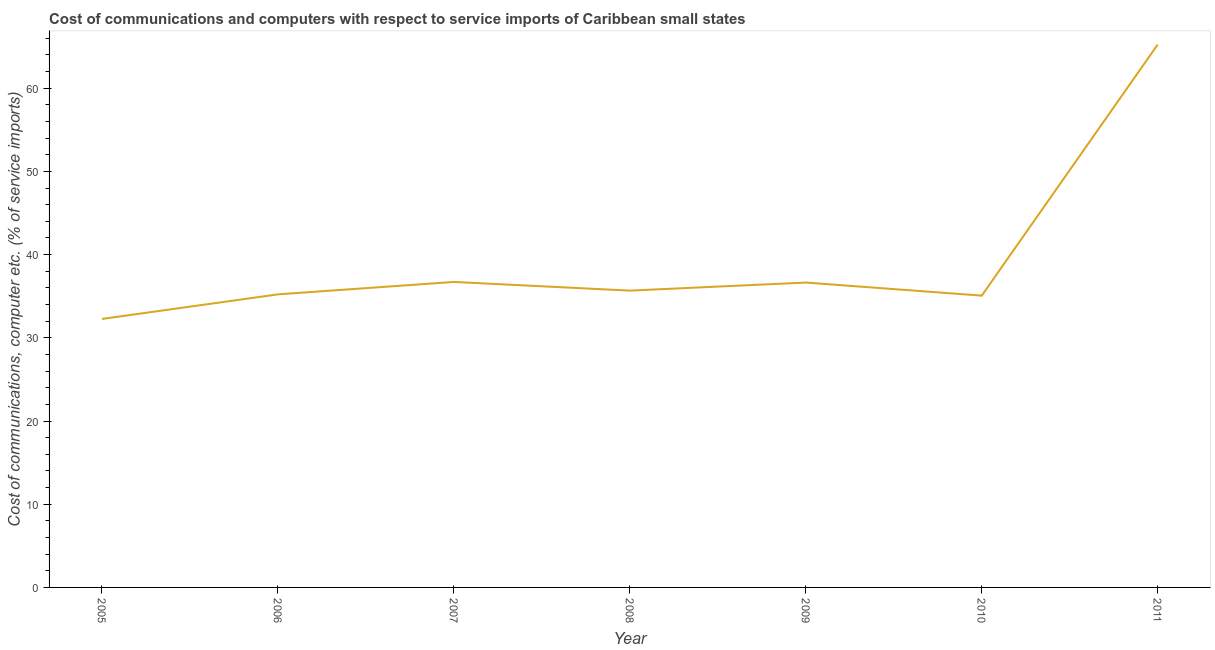What is the cost of communications and computer in 2006?
Give a very brief answer. 35.22. Across all years, what is the maximum cost of communications and computer?
Give a very brief answer. 65.25. Across all years, what is the minimum cost of communications and computer?
Your response must be concise. 32.27. In which year was the cost of communications and computer maximum?
Your response must be concise. 2011. In which year was the cost of communications and computer minimum?
Keep it short and to the point. 2005. What is the sum of the cost of communications and computer?
Your answer should be very brief. 276.83. What is the difference between the cost of communications and computer in 2006 and 2011?
Your answer should be compact. -30.02. What is the average cost of communications and computer per year?
Provide a succinct answer. 39.55. What is the median cost of communications and computer?
Make the answer very short. 35.67. What is the ratio of the cost of communications and computer in 2006 to that in 2007?
Your answer should be compact. 0.96. Is the cost of communications and computer in 2005 less than that in 2009?
Provide a short and direct response. Yes. Is the difference between the cost of communications and computer in 2007 and 2009 greater than the difference between any two years?
Provide a succinct answer. No. What is the difference between the highest and the second highest cost of communications and computer?
Offer a very short reply. 28.53. Is the sum of the cost of communications and computer in 2010 and 2011 greater than the maximum cost of communications and computer across all years?
Your answer should be very brief. Yes. What is the difference between the highest and the lowest cost of communications and computer?
Your answer should be very brief. 32.98. Are the values on the major ticks of Y-axis written in scientific E-notation?
Make the answer very short. No. What is the title of the graph?
Offer a very short reply. Cost of communications and computers with respect to service imports of Caribbean small states. What is the label or title of the Y-axis?
Your answer should be compact. Cost of communications, computer etc. (% of service imports). What is the Cost of communications, computer etc. (% of service imports) in 2005?
Offer a terse response. 32.27. What is the Cost of communications, computer etc. (% of service imports) of 2006?
Your response must be concise. 35.22. What is the Cost of communications, computer etc. (% of service imports) in 2007?
Offer a terse response. 36.71. What is the Cost of communications, computer etc. (% of service imports) in 2008?
Give a very brief answer. 35.67. What is the Cost of communications, computer etc. (% of service imports) in 2009?
Offer a terse response. 36.64. What is the Cost of communications, computer etc. (% of service imports) of 2010?
Your response must be concise. 35.07. What is the Cost of communications, computer etc. (% of service imports) in 2011?
Your response must be concise. 65.25. What is the difference between the Cost of communications, computer etc. (% of service imports) in 2005 and 2006?
Give a very brief answer. -2.96. What is the difference between the Cost of communications, computer etc. (% of service imports) in 2005 and 2007?
Make the answer very short. -4.45. What is the difference between the Cost of communications, computer etc. (% of service imports) in 2005 and 2008?
Ensure brevity in your answer.  -3.4. What is the difference between the Cost of communications, computer etc. (% of service imports) in 2005 and 2009?
Make the answer very short. -4.37. What is the difference between the Cost of communications, computer etc. (% of service imports) in 2005 and 2010?
Provide a succinct answer. -2.8. What is the difference between the Cost of communications, computer etc. (% of service imports) in 2005 and 2011?
Offer a terse response. -32.98. What is the difference between the Cost of communications, computer etc. (% of service imports) in 2006 and 2007?
Keep it short and to the point. -1.49. What is the difference between the Cost of communications, computer etc. (% of service imports) in 2006 and 2008?
Your answer should be compact. -0.45. What is the difference between the Cost of communications, computer etc. (% of service imports) in 2006 and 2009?
Offer a very short reply. -1.42. What is the difference between the Cost of communications, computer etc. (% of service imports) in 2006 and 2010?
Keep it short and to the point. 0.15. What is the difference between the Cost of communications, computer etc. (% of service imports) in 2006 and 2011?
Your answer should be very brief. -30.02. What is the difference between the Cost of communications, computer etc. (% of service imports) in 2007 and 2008?
Offer a very short reply. 1.04. What is the difference between the Cost of communications, computer etc. (% of service imports) in 2007 and 2009?
Offer a terse response. 0.07. What is the difference between the Cost of communications, computer etc. (% of service imports) in 2007 and 2010?
Make the answer very short. 1.65. What is the difference between the Cost of communications, computer etc. (% of service imports) in 2007 and 2011?
Keep it short and to the point. -28.53. What is the difference between the Cost of communications, computer etc. (% of service imports) in 2008 and 2009?
Your answer should be compact. -0.97. What is the difference between the Cost of communications, computer etc. (% of service imports) in 2008 and 2010?
Offer a very short reply. 0.6. What is the difference between the Cost of communications, computer etc. (% of service imports) in 2008 and 2011?
Provide a short and direct response. -29.58. What is the difference between the Cost of communications, computer etc. (% of service imports) in 2009 and 2010?
Offer a terse response. 1.57. What is the difference between the Cost of communications, computer etc. (% of service imports) in 2009 and 2011?
Provide a short and direct response. -28.6. What is the difference between the Cost of communications, computer etc. (% of service imports) in 2010 and 2011?
Ensure brevity in your answer.  -30.18. What is the ratio of the Cost of communications, computer etc. (% of service imports) in 2005 to that in 2006?
Make the answer very short. 0.92. What is the ratio of the Cost of communications, computer etc. (% of service imports) in 2005 to that in 2007?
Offer a terse response. 0.88. What is the ratio of the Cost of communications, computer etc. (% of service imports) in 2005 to that in 2008?
Provide a succinct answer. 0.91. What is the ratio of the Cost of communications, computer etc. (% of service imports) in 2005 to that in 2009?
Your response must be concise. 0.88. What is the ratio of the Cost of communications, computer etc. (% of service imports) in 2005 to that in 2011?
Keep it short and to the point. 0.49. What is the ratio of the Cost of communications, computer etc. (% of service imports) in 2006 to that in 2011?
Make the answer very short. 0.54. What is the ratio of the Cost of communications, computer etc. (% of service imports) in 2007 to that in 2008?
Make the answer very short. 1.03. What is the ratio of the Cost of communications, computer etc. (% of service imports) in 2007 to that in 2010?
Give a very brief answer. 1.05. What is the ratio of the Cost of communications, computer etc. (% of service imports) in 2007 to that in 2011?
Keep it short and to the point. 0.56. What is the ratio of the Cost of communications, computer etc. (% of service imports) in 2008 to that in 2009?
Your answer should be very brief. 0.97. What is the ratio of the Cost of communications, computer etc. (% of service imports) in 2008 to that in 2010?
Give a very brief answer. 1.02. What is the ratio of the Cost of communications, computer etc. (% of service imports) in 2008 to that in 2011?
Make the answer very short. 0.55. What is the ratio of the Cost of communications, computer etc. (% of service imports) in 2009 to that in 2010?
Provide a short and direct response. 1.04. What is the ratio of the Cost of communications, computer etc. (% of service imports) in 2009 to that in 2011?
Provide a succinct answer. 0.56. What is the ratio of the Cost of communications, computer etc. (% of service imports) in 2010 to that in 2011?
Provide a succinct answer. 0.54. 